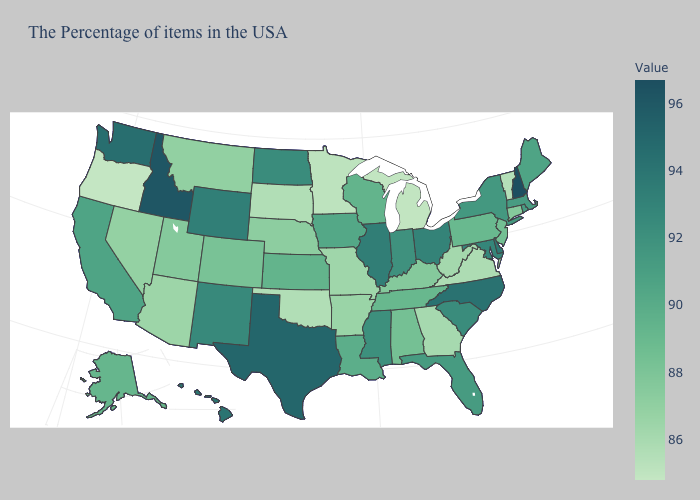Which states have the lowest value in the South?
Be succinct. Oklahoma. Does Alaska have a higher value than Vermont?
Give a very brief answer. Yes. Among the states that border Vermont , which have the lowest value?
Concise answer only. Massachusetts. Is the legend a continuous bar?
Answer briefly. Yes. Among the states that border West Virginia , which have the lowest value?
Keep it brief. Virginia. Does Texas have the lowest value in the USA?
Write a very short answer. No. Does Rhode Island have the highest value in the Northeast?
Answer briefly. No. 